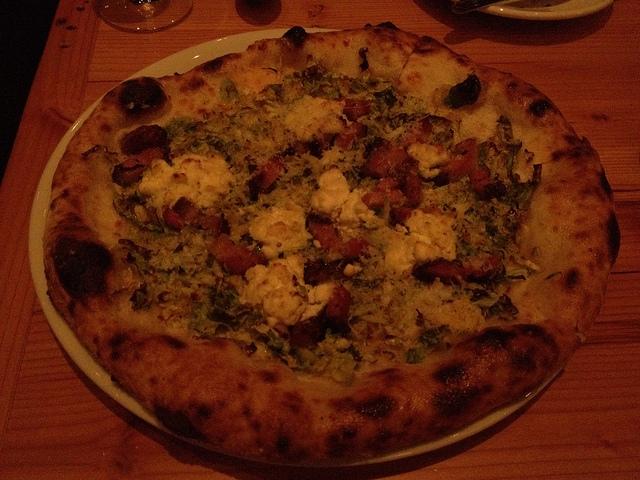Does the pizza look delicious?
Write a very short answer. Yes. What type of food is on plate?
Quick response, please. Pizza. Is there a napkin in this picture?
Answer briefly. No. Why is the image dark?
Quick response, please. Bad lighting. Can you tell if this is part of a pizza?
Answer briefly. Yes. Does the crust looked burnt?
Answer briefly. Yes. Is this a vegetarian dish?
Short answer required. No. Is the pizza good?
Concise answer only. Yes. Is this a balanced meal?
Give a very brief answer. No. Is there a pizza cutter in the image?
Give a very brief answer. No. Is this pizza overcooked?
Write a very short answer. Yes. Has the pizza been cut?
Keep it brief. No. 